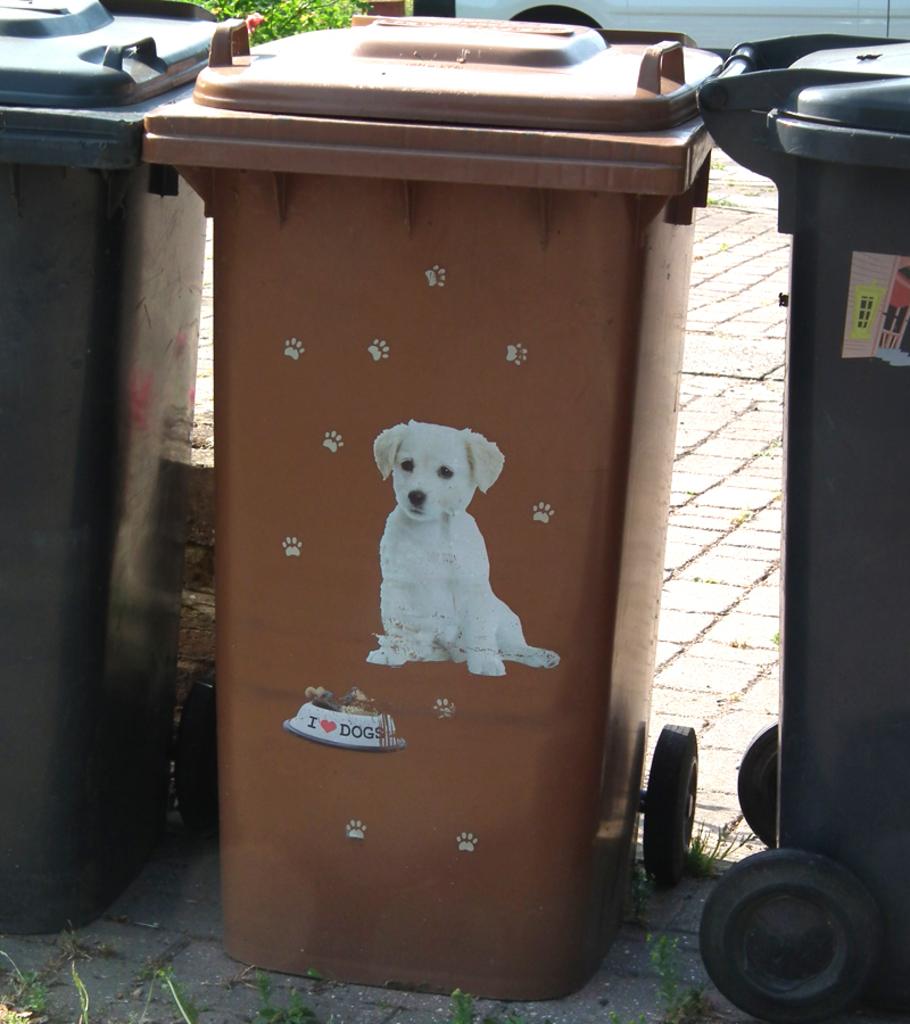What does the dog bowl say on the trash bin?
Your response must be concise. I love dogs. 